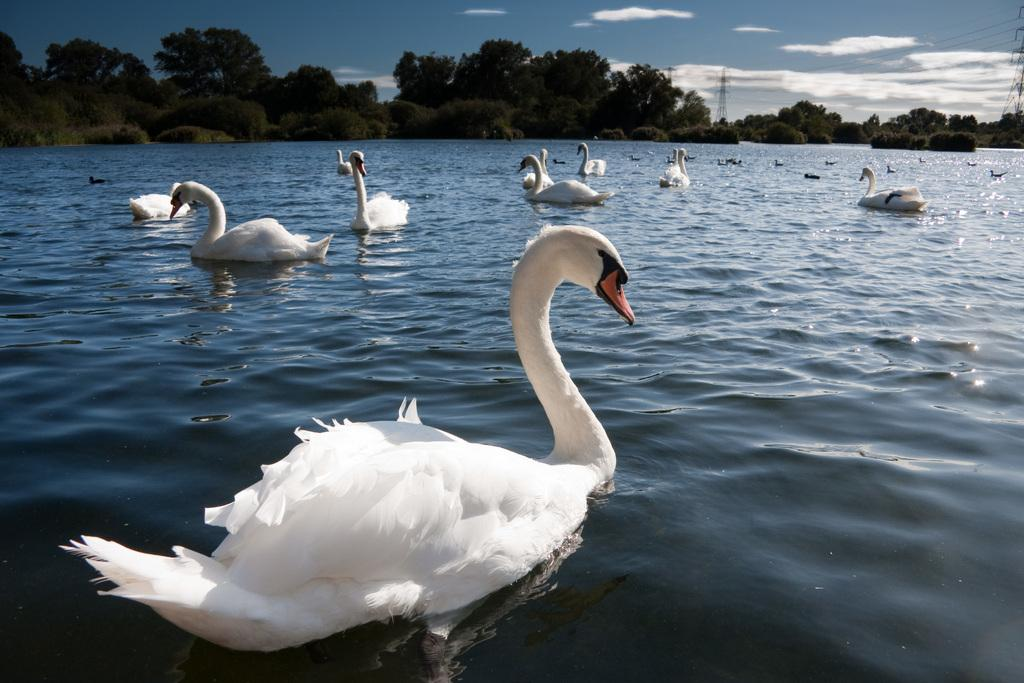What animals can be seen in the image? There are ducks floating on the lake in the image. What type of vegetation is visible in the image? There are trees visible in the image. What part of the natural environment is visible in the image? The sky is visible in the image, and clouds are present in the sky. What man-made structures can be seen in the image? Transmission towers are present in the image. Can you describe the hill in the background of the image? There is no hill present in the image; it features ducks floating on a lake, trees, the sky, clouds, and transmission towers. What type of apparatus is being used by the stranger in the image? There is no stranger present in the image, and therefore no apparatus can be observed. 